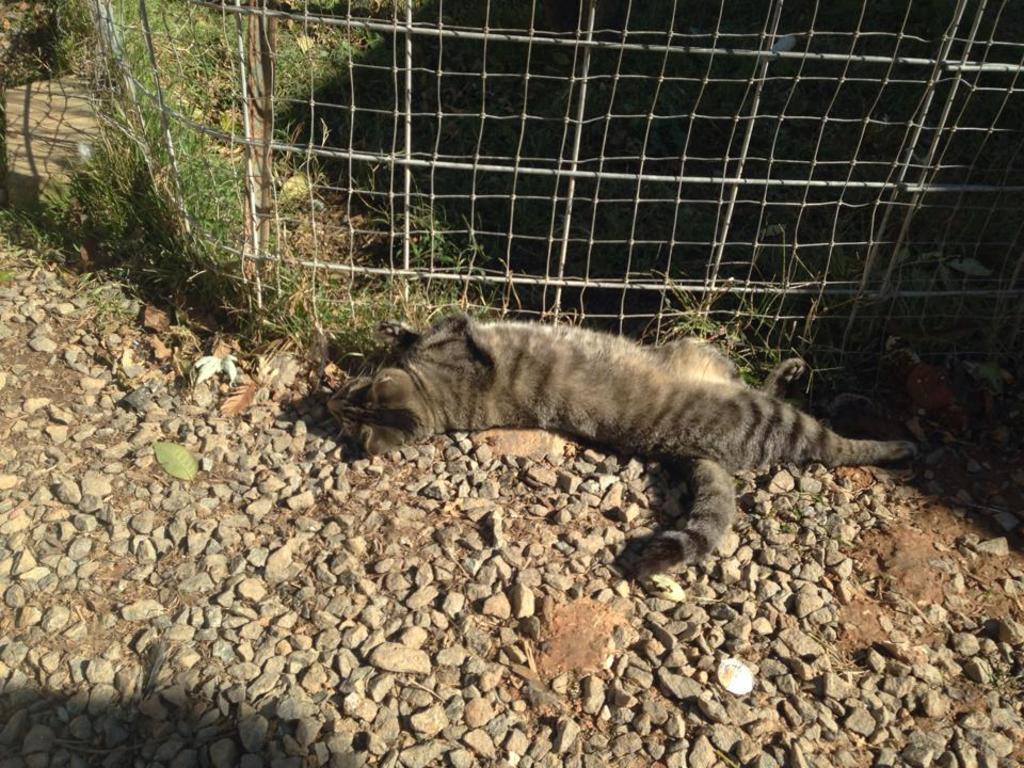Can you describe this image briefly? In this image I can see a cat which is black and ash in color is laying on the ground. I can see few stones on the ground. I can see some grass and the fencing. 